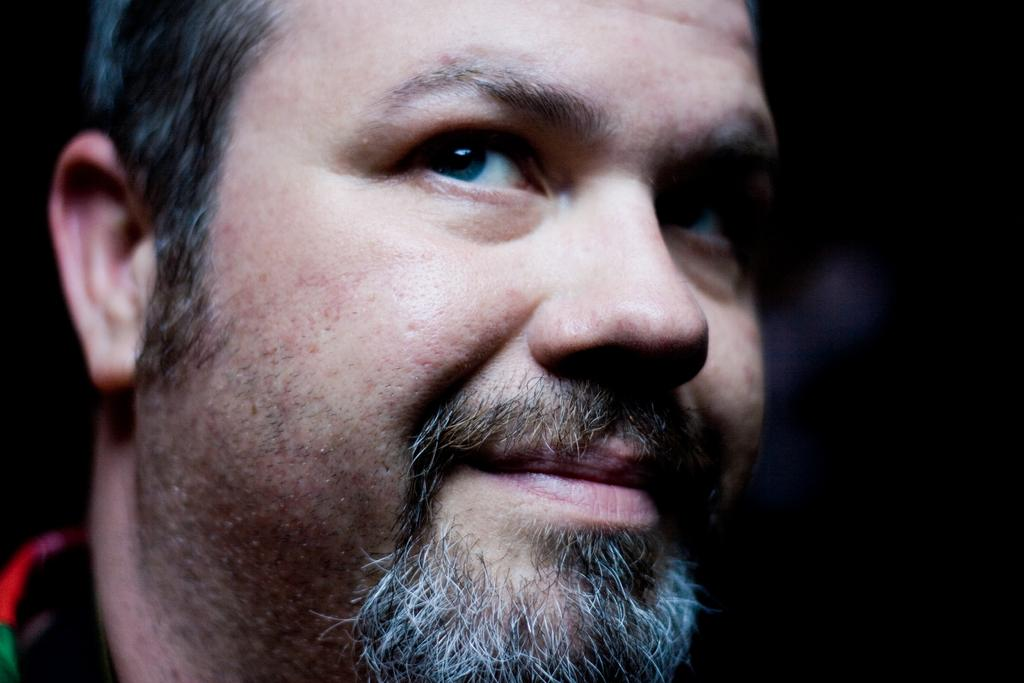Who is the main subject in the image? There is a man in the image. What can be observed about the background of the image? The background of the image is blurred. What type of paper is the man holding in the image? There is no paper present in the image; the man is the only subject visible. 